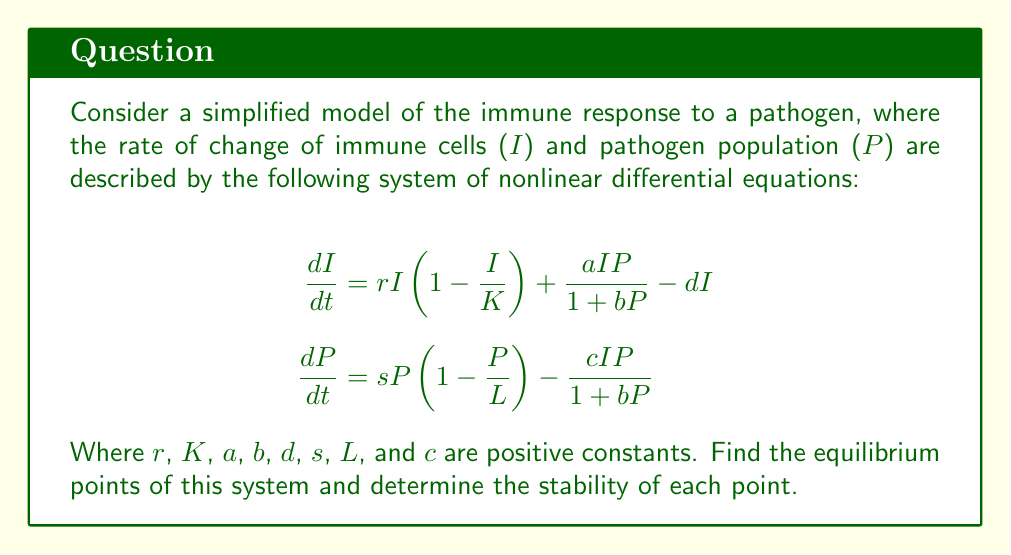Teach me how to tackle this problem. To find the equilibrium points, we set both equations equal to zero and solve for I and P:

1) Set $\frac{dI}{dt} = 0$ and $\frac{dP}{dt} = 0$:

   $$rI\left(1-\frac{I}{K}\right) + \frac{aIP}{1+bP} - dI = 0$$
   $$sP\left(1-\frac{P}{L}\right) - \frac{cIP}{1+bP} = 0$$

2) From the second equation, we can see that $P = 0$ is a solution. Let's first consider this case:

   If $P = 0$, from the first equation:
   $$rI\left(1-\frac{I}{K}\right) - dI = 0$$
   $$I(r-d-\frac{rI}{K}) = 0$$
   
   This gives us two solutions: $I = 0$ or $I = K(1-\frac{d}{r})$ if $r > d$

3) Now, let's consider the case where $P \neq 0$. From the second equation:

   $$s\left(1-\frac{P}{L}\right) = \frac{cI}{1+bP}$$
   $$I = \frac{s(1+bP)(L-P)}{cL}$$

4) Substituting this into the first equation:

   $$r\frac{s(1+bP)(L-P)}{cL}\left(1-\frac{s(1+bP)(L-P)}{cLK}\right) + \frac{as(1+bP)(L-P)P}{cL(1+bP)} - d\frac{s(1+bP)(L-P)}{cL} = 0$$

5) This is a complex polynomial equation in P. Solving it analytically is challenging and would typically require numerical methods. However, we can identify the equilibrium points:

   - $(0,0)$
   - $(K(1-\frac{d}{r}),0)$ if $r > d$
   - $(I^*,P^*)$ where $I^*$ and $P^*$ are positive solutions to the equation in step 4

6) To determine stability, we would need to evaluate the Jacobian matrix at each equilibrium point and analyze its eigenvalues. This is a complex process and would require further numerical analysis.
Answer: Equilibrium points: $(0,0)$, $(K(1-\frac{d}{r}),0)$ if $r > d$, and $(I^*,P^*)$ where $I^*$ and $P^*$ are positive solutions to the nonlinear equation. 